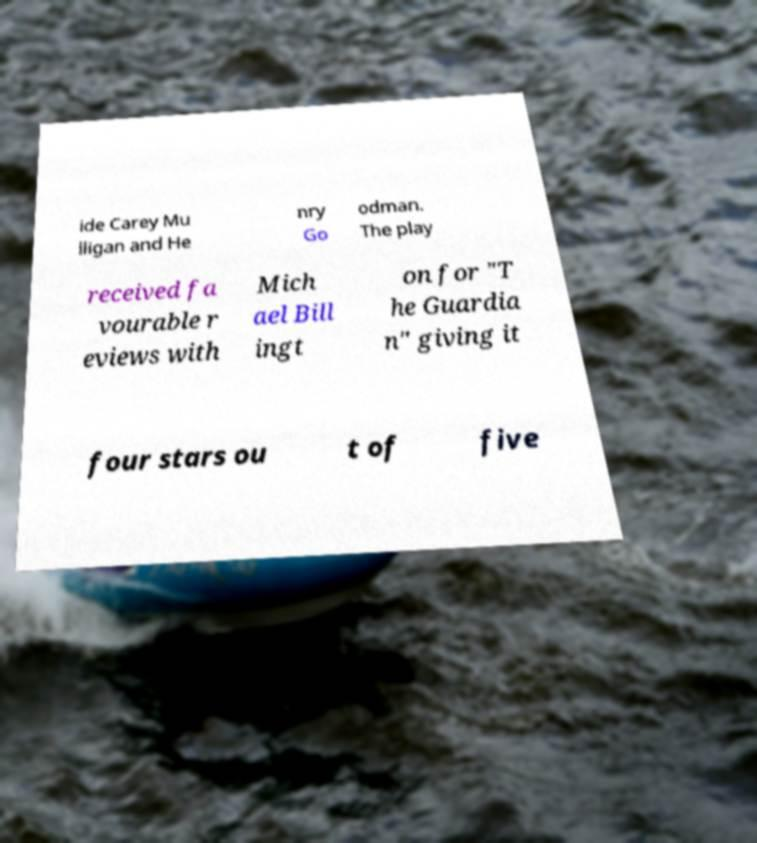Can you accurately transcribe the text from the provided image for me? ide Carey Mu lligan and He nry Go odman. The play received fa vourable r eviews with Mich ael Bill ingt on for "T he Guardia n" giving it four stars ou t of five 